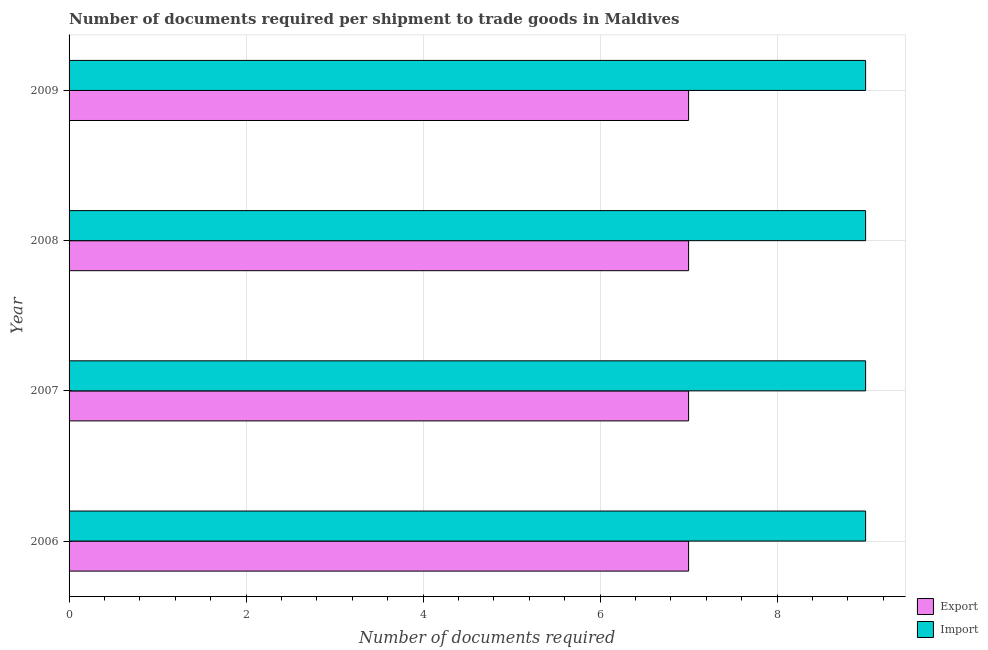Are the number of bars per tick equal to the number of legend labels?
Your answer should be very brief. Yes. Are the number of bars on each tick of the Y-axis equal?
Offer a terse response. Yes. How many bars are there on the 2nd tick from the top?
Offer a very short reply. 2. What is the number of documents required to export goods in 2006?
Keep it short and to the point. 7. Across all years, what is the maximum number of documents required to import goods?
Your answer should be very brief. 9. Across all years, what is the minimum number of documents required to import goods?
Your response must be concise. 9. In which year was the number of documents required to export goods minimum?
Your answer should be compact. 2006. What is the total number of documents required to export goods in the graph?
Offer a very short reply. 28. What is the difference between the number of documents required to export goods in 2006 and that in 2009?
Ensure brevity in your answer.  0. What is the difference between the number of documents required to import goods in 2008 and the number of documents required to export goods in 2007?
Offer a terse response. 2. What is the average number of documents required to export goods per year?
Offer a very short reply. 7. In the year 2009, what is the difference between the number of documents required to import goods and number of documents required to export goods?
Keep it short and to the point. 2. What is the difference between the highest and the second highest number of documents required to import goods?
Your answer should be compact. 0. In how many years, is the number of documents required to export goods greater than the average number of documents required to export goods taken over all years?
Offer a very short reply. 0. Is the sum of the number of documents required to export goods in 2008 and 2009 greater than the maximum number of documents required to import goods across all years?
Provide a short and direct response. Yes. What does the 2nd bar from the top in 2008 represents?
Ensure brevity in your answer.  Export. What does the 2nd bar from the bottom in 2008 represents?
Give a very brief answer. Import. How many bars are there?
Offer a terse response. 8. Are all the bars in the graph horizontal?
Provide a short and direct response. Yes. What is the difference between two consecutive major ticks on the X-axis?
Make the answer very short. 2. Are the values on the major ticks of X-axis written in scientific E-notation?
Provide a short and direct response. No. Does the graph contain any zero values?
Give a very brief answer. No. How many legend labels are there?
Make the answer very short. 2. What is the title of the graph?
Give a very brief answer. Number of documents required per shipment to trade goods in Maldives. What is the label or title of the X-axis?
Keep it short and to the point. Number of documents required. What is the Number of documents required of Import in 2006?
Offer a very short reply. 9. What is the Number of documents required of Import in 2007?
Your answer should be compact. 9. What is the Number of documents required of Import in 2009?
Offer a very short reply. 9. Across all years, what is the maximum Number of documents required in Export?
Your response must be concise. 7. What is the difference between the Number of documents required of Export in 2006 and that in 2007?
Your answer should be compact. 0. What is the difference between the Number of documents required in Export in 2006 and that in 2008?
Your response must be concise. 0. What is the difference between the Number of documents required in Export in 2007 and that in 2008?
Your answer should be very brief. 0. What is the difference between the Number of documents required of Import in 2007 and that in 2008?
Provide a succinct answer. 0. What is the difference between the Number of documents required in Import in 2007 and that in 2009?
Offer a very short reply. 0. What is the difference between the Number of documents required of Import in 2008 and that in 2009?
Provide a short and direct response. 0. What is the difference between the Number of documents required in Export in 2006 and the Number of documents required in Import in 2007?
Your answer should be compact. -2. What is the difference between the Number of documents required of Export in 2006 and the Number of documents required of Import in 2008?
Your response must be concise. -2. What is the difference between the Number of documents required of Export in 2006 and the Number of documents required of Import in 2009?
Provide a short and direct response. -2. What is the difference between the Number of documents required of Export in 2008 and the Number of documents required of Import in 2009?
Ensure brevity in your answer.  -2. What is the average Number of documents required in Export per year?
Your answer should be very brief. 7. In the year 2006, what is the difference between the Number of documents required of Export and Number of documents required of Import?
Your response must be concise. -2. In the year 2007, what is the difference between the Number of documents required of Export and Number of documents required of Import?
Ensure brevity in your answer.  -2. What is the ratio of the Number of documents required in Export in 2006 to that in 2007?
Your response must be concise. 1. What is the ratio of the Number of documents required in Import in 2006 to that in 2007?
Make the answer very short. 1. What is the ratio of the Number of documents required in Import in 2006 to that in 2008?
Offer a very short reply. 1. What is the ratio of the Number of documents required of Export in 2007 to that in 2009?
Provide a succinct answer. 1. What is the ratio of the Number of documents required of Import in 2008 to that in 2009?
Ensure brevity in your answer.  1. What is the difference between the highest and the second highest Number of documents required in Export?
Your answer should be very brief. 0. What is the difference between the highest and the lowest Number of documents required of Import?
Offer a very short reply. 0. 